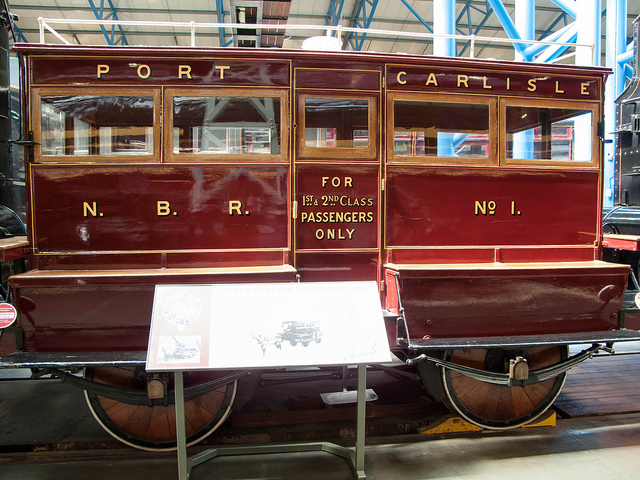Read and extract the text from this image. PORT CARLISLE NO FOR PASSENGERS 1 1ST 2ND CLASS ONLY R B N 